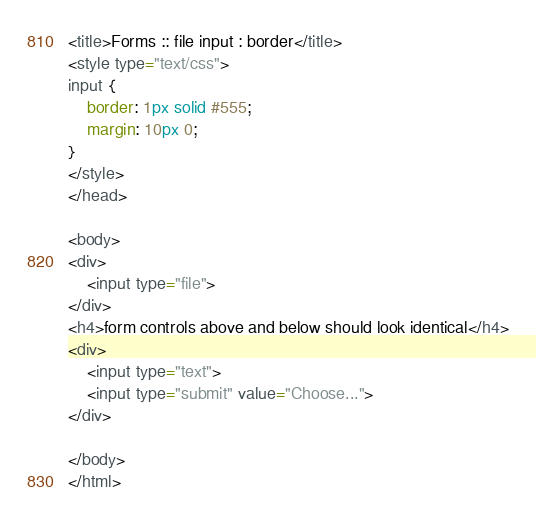<code> <loc_0><loc_0><loc_500><loc_500><_HTML_><title>Forms :: file input : border</title>
<style type="text/css">
input {
	border: 1px solid #555;
	margin: 10px 0;
}
</style>
</head>

<body>
<div>
	<input type="file">
</div>
<h4>form controls above and below should look identical</h4>
<div>
	<input type="text">
	<input type="submit" value="Choose...">
</div>

</body>
</html>

</code> 